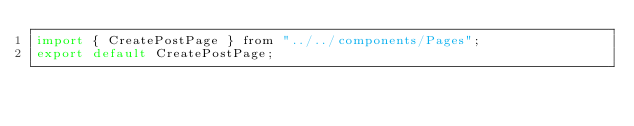<code> <loc_0><loc_0><loc_500><loc_500><_JavaScript_>import { CreatePostPage } from "../../components/Pages";
export default CreatePostPage;
</code> 